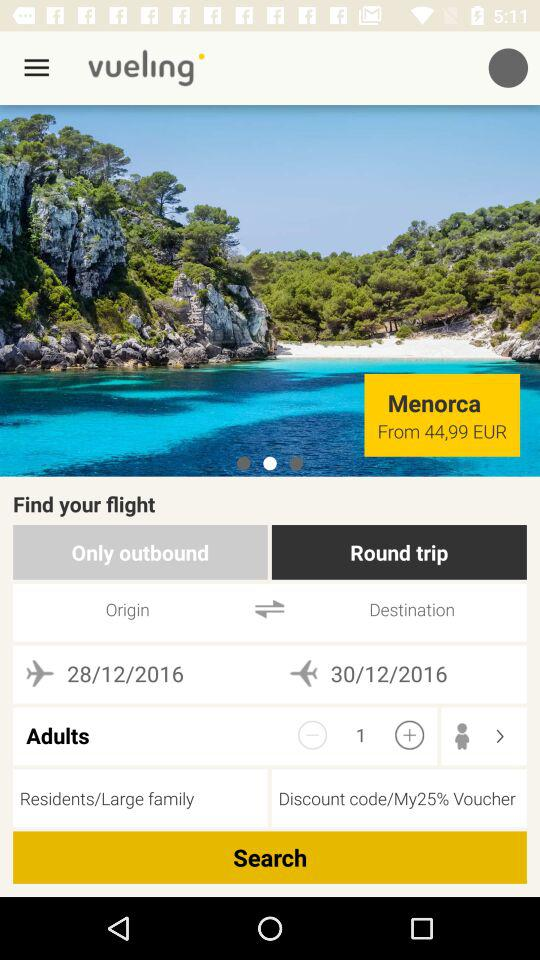For how many seats is the flight booking process in progress? The flight booking process in progress is for 1 seat. 